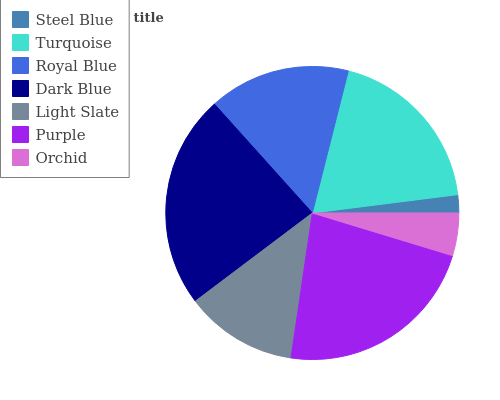Is Steel Blue the minimum?
Answer yes or no. Yes. Is Dark Blue the maximum?
Answer yes or no. Yes. Is Turquoise the minimum?
Answer yes or no. No. Is Turquoise the maximum?
Answer yes or no. No. Is Turquoise greater than Steel Blue?
Answer yes or no. Yes. Is Steel Blue less than Turquoise?
Answer yes or no. Yes. Is Steel Blue greater than Turquoise?
Answer yes or no. No. Is Turquoise less than Steel Blue?
Answer yes or no. No. Is Royal Blue the high median?
Answer yes or no. Yes. Is Royal Blue the low median?
Answer yes or no. Yes. Is Purple the high median?
Answer yes or no. No. Is Orchid the low median?
Answer yes or no. No. 